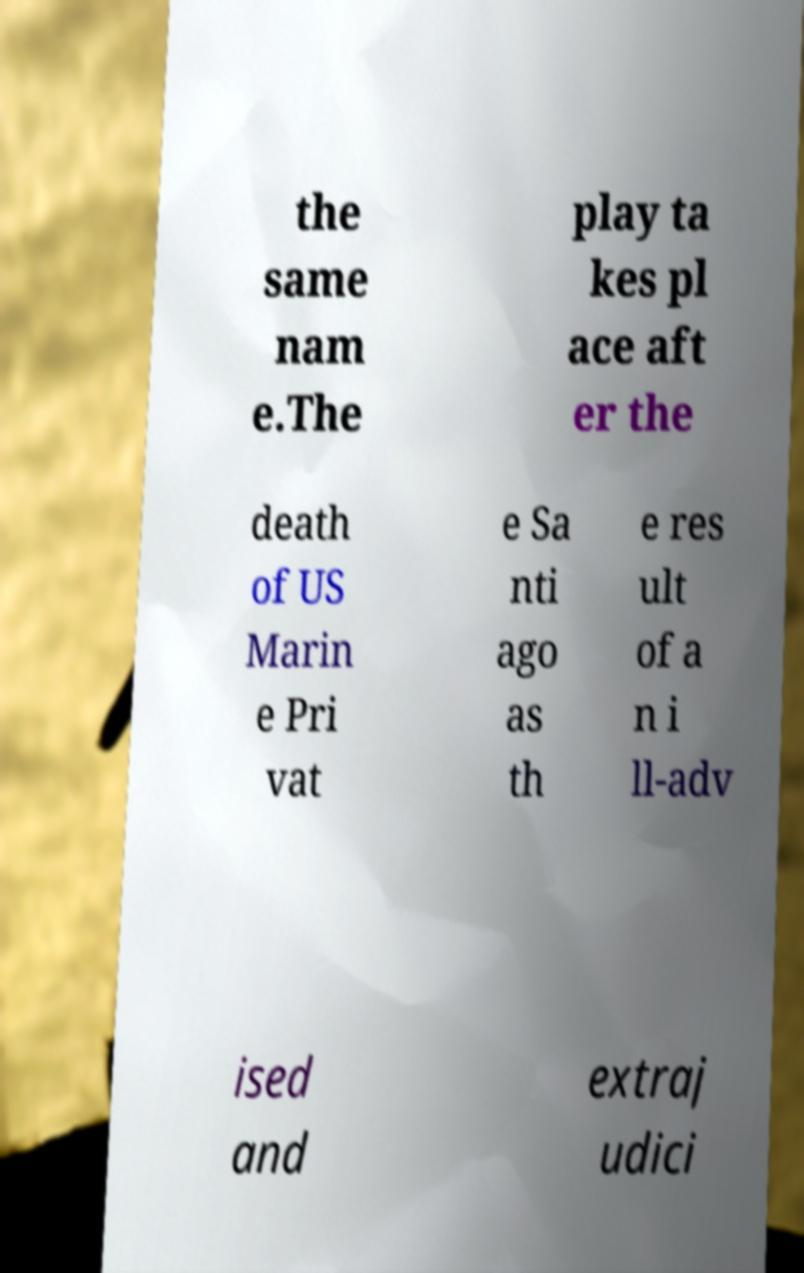Can you read and provide the text displayed in the image?This photo seems to have some interesting text. Can you extract and type it out for me? the same nam e.The play ta kes pl ace aft er the death of US Marin e Pri vat e Sa nti ago as th e res ult of a n i ll-adv ised and extraj udici 